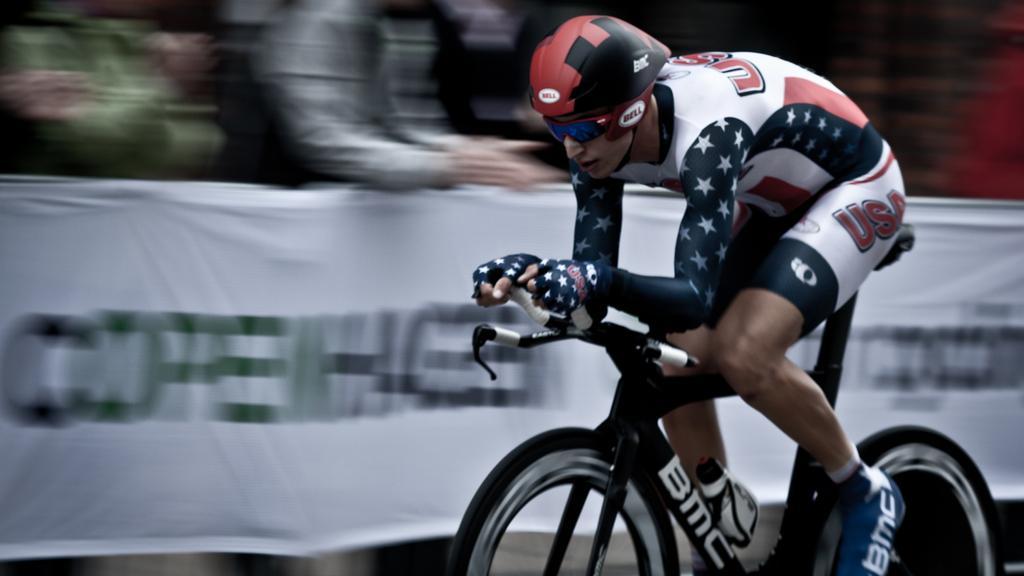In one or two sentences, can you explain what this image depicts? Background of the picture is very blurry. Here we can see a banner. Here we can see one man sitting on a bicycle and riding. He wore goggles and a helmet. 